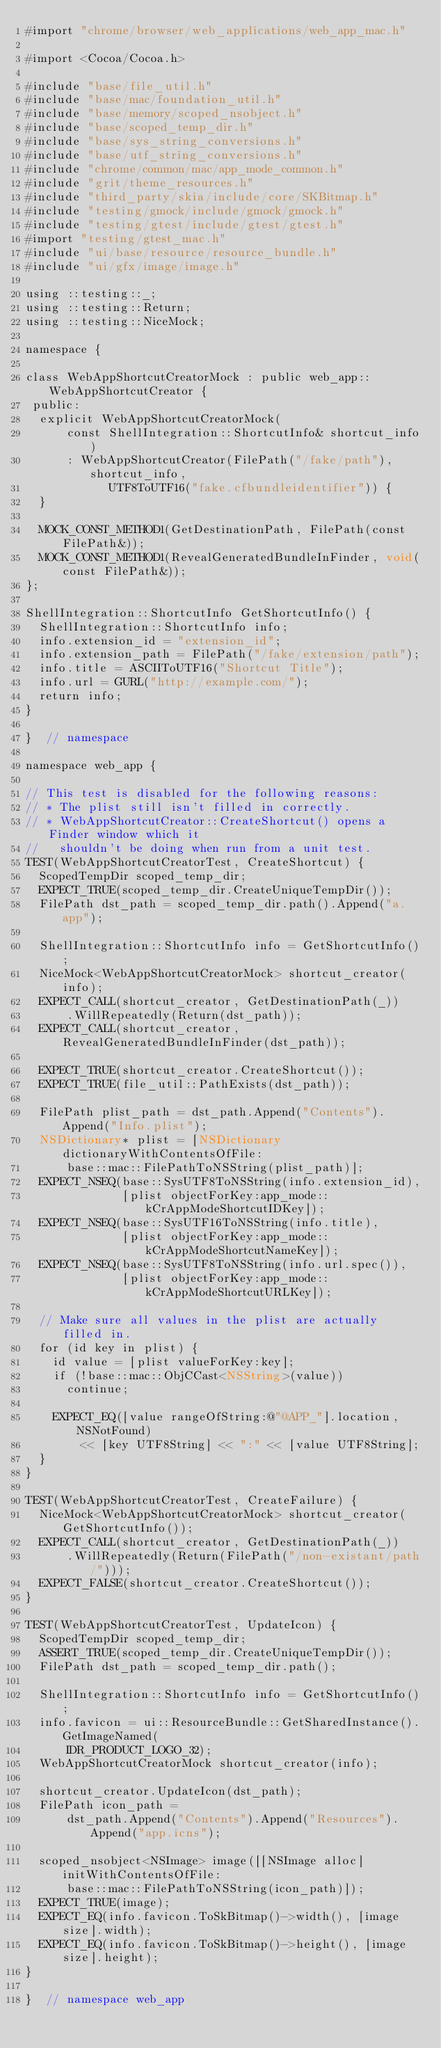<code> <loc_0><loc_0><loc_500><loc_500><_ObjectiveC_>#import "chrome/browser/web_applications/web_app_mac.h"

#import <Cocoa/Cocoa.h>

#include "base/file_util.h"
#include "base/mac/foundation_util.h"
#include "base/memory/scoped_nsobject.h"
#include "base/scoped_temp_dir.h"
#include "base/sys_string_conversions.h"
#include "base/utf_string_conversions.h"
#include "chrome/common/mac/app_mode_common.h"
#include "grit/theme_resources.h"
#include "third_party/skia/include/core/SKBitmap.h"
#include "testing/gmock/include/gmock/gmock.h"
#include "testing/gtest/include/gtest/gtest.h"
#import "testing/gtest_mac.h"
#include "ui/base/resource/resource_bundle.h"
#include "ui/gfx/image/image.h"

using ::testing::_;
using ::testing::Return;
using ::testing::NiceMock;

namespace {

class WebAppShortcutCreatorMock : public web_app::WebAppShortcutCreator {
 public:
  explicit WebAppShortcutCreatorMock(
      const ShellIntegration::ShortcutInfo& shortcut_info)
      : WebAppShortcutCreator(FilePath("/fake/path"), shortcut_info,
            UTF8ToUTF16("fake.cfbundleidentifier")) {
  }

  MOCK_CONST_METHOD1(GetDestinationPath, FilePath(const FilePath&));
  MOCK_CONST_METHOD1(RevealGeneratedBundleInFinder, void(const FilePath&));
};

ShellIntegration::ShortcutInfo GetShortcutInfo() {
  ShellIntegration::ShortcutInfo info;
  info.extension_id = "extension_id";
  info.extension_path = FilePath("/fake/extension/path");
  info.title = ASCIIToUTF16("Shortcut Title");
  info.url = GURL("http://example.com/");
  return info;
}

}  // namespace

namespace web_app {

// This test is disabled for the following reasons:
// * The plist still isn't filled in correctly.
// * WebAppShortcutCreator::CreateShortcut() opens a Finder window which it
//   shouldn't be doing when run from a unit test.
TEST(WebAppShortcutCreatorTest, CreateShortcut) {
  ScopedTempDir scoped_temp_dir;
  EXPECT_TRUE(scoped_temp_dir.CreateUniqueTempDir());
  FilePath dst_path = scoped_temp_dir.path().Append("a.app");

  ShellIntegration::ShortcutInfo info = GetShortcutInfo();
  NiceMock<WebAppShortcutCreatorMock> shortcut_creator(info);
  EXPECT_CALL(shortcut_creator, GetDestinationPath(_))
      .WillRepeatedly(Return(dst_path));
  EXPECT_CALL(shortcut_creator, RevealGeneratedBundleInFinder(dst_path));

  EXPECT_TRUE(shortcut_creator.CreateShortcut());
  EXPECT_TRUE(file_util::PathExists(dst_path));

  FilePath plist_path = dst_path.Append("Contents").Append("Info.plist");
  NSDictionary* plist = [NSDictionary dictionaryWithContentsOfFile:
      base::mac::FilePathToNSString(plist_path)];
  EXPECT_NSEQ(base::SysUTF8ToNSString(info.extension_id),
              [plist objectForKey:app_mode::kCrAppModeShortcutIDKey]);
  EXPECT_NSEQ(base::SysUTF16ToNSString(info.title),
              [plist objectForKey:app_mode::kCrAppModeShortcutNameKey]);
  EXPECT_NSEQ(base::SysUTF8ToNSString(info.url.spec()),
              [plist objectForKey:app_mode::kCrAppModeShortcutURLKey]);

  // Make sure all values in the plist are actually filled in.
  for (id key in plist) {
    id value = [plist valueForKey:key];
    if (!base::mac::ObjCCast<NSString>(value))
      continue;

    EXPECT_EQ([value rangeOfString:@"@APP_"].location, NSNotFound)
        << [key UTF8String] << ":" << [value UTF8String];
  }
}

TEST(WebAppShortcutCreatorTest, CreateFailure) {
  NiceMock<WebAppShortcutCreatorMock> shortcut_creator(GetShortcutInfo());
  EXPECT_CALL(shortcut_creator, GetDestinationPath(_))
      .WillRepeatedly(Return(FilePath("/non-existant/path/")));
  EXPECT_FALSE(shortcut_creator.CreateShortcut());
}

TEST(WebAppShortcutCreatorTest, UpdateIcon) {
  ScopedTempDir scoped_temp_dir;
  ASSERT_TRUE(scoped_temp_dir.CreateUniqueTempDir());
  FilePath dst_path = scoped_temp_dir.path();

  ShellIntegration::ShortcutInfo info = GetShortcutInfo();
  info.favicon = ui::ResourceBundle::GetSharedInstance().GetImageNamed(
      IDR_PRODUCT_LOGO_32);
  WebAppShortcutCreatorMock shortcut_creator(info);

  shortcut_creator.UpdateIcon(dst_path);
  FilePath icon_path =
      dst_path.Append("Contents").Append("Resources").Append("app.icns");

  scoped_nsobject<NSImage> image([[NSImage alloc] initWithContentsOfFile:
      base::mac::FilePathToNSString(icon_path)]);
  EXPECT_TRUE(image);
  EXPECT_EQ(info.favicon.ToSkBitmap()->width(), [image size].width);
  EXPECT_EQ(info.favicon.ToSkBitmap()->height(), [image size].height);
}

}  // namespace web_app
</code> 